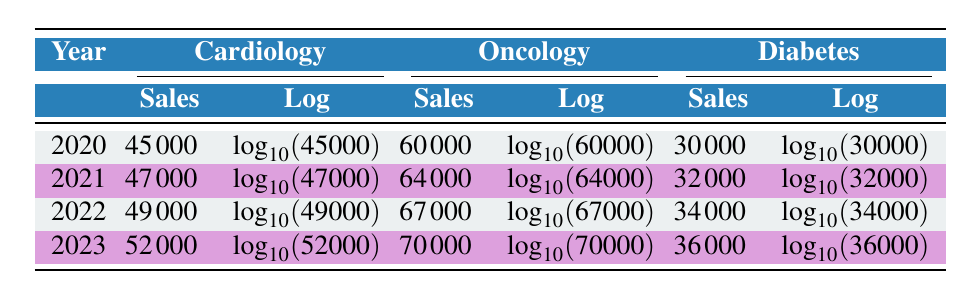What were the sales figures for Oncology in 2020? The table lists sales for Oncology in the year 2020 as 60000 million. This value is explicitly stated in the table under the corresponding row and column.
Answer: 60000 Which therapeutic area had the highest sales in 2021? By comparing the sales figures for each therapeutic area in 2021, Cardiology has 47000 million, Oncology has 64000 million, and Diabetes has 32000 million. The highest value is for Oncology.
Answer: Oncology What is the difference in sales between Cardiology in 2022 and Cardiology in 2020? Cardiology sales in 2022 is 49000 million and in 2020 it is 45000 million. The difference can be calculated as 49000 - 45000 = 4000 million.
Answer: 4000 Did sales for Diabetes increase from 2020 to 2023? Comparing the sales from 2020 (30000 million) to 2023 (36000 million), there is an increase, confirming that sales have gone up over this period.
Answer: Yes What is the average sales figure for Oncology over the four years listed? The sales figures for Oncology are 60000 (2020), 64000 (2021), 67000 (2022), and 70000 (2023). Adding these yields a sum of 264000 million. Dividing by the number of years (4) gives an average of 264000 / 4 = 66000 million.
Answer: 66000 Which year saw the smallest increase in Cardiology sales compared to the previous year? The increases for each year are: 2021 vs 2020 (47000 - 45000), 2022 vs 2021 (49000 - 47000), and 2023 vs 2022 (52000 - 49000), resulting in increases of 2000, 2000, and 3000 million respectively. The smallest increase is 2000 million, occurring in both 2021 and 2022.
Answer: 2021 and 2022 Was the total sales for Diabetes higher in 2022 compared to 2020? The sales for Diabetes in 2020 are 30000 million, while in 2022 they are 34000 million. Since 34000 is greater than 30000, this confirms the total sales was higher in 2022.
Answer: Yes 